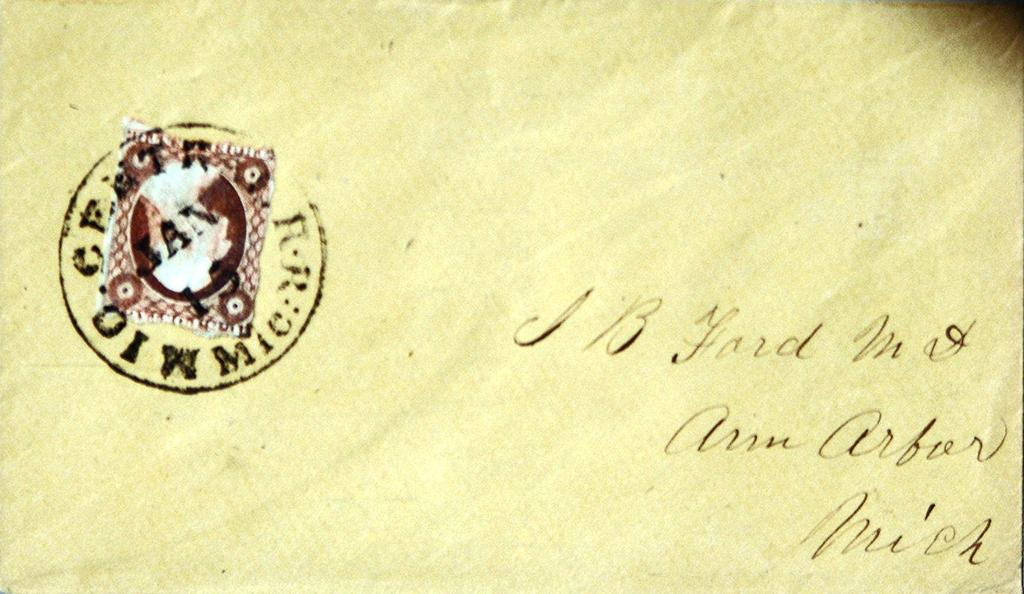<image>
Present a compact description of the photo's key features. An envelope is addressed to Ann Arbor and is stamped in the corner. 